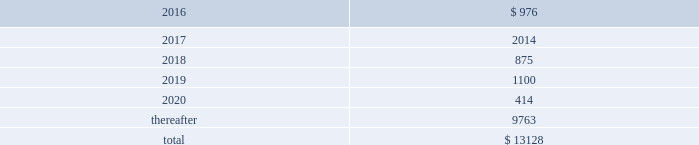Devon energy corporation and subsidiaries notes to consolidated financial statements 2013 ( continued ) debt maturities as of december 31 , 2015 , excluding premiums and discounts , are as follows ( millions ) : .
Credit lines devon has a $ 3.0 billion senior credit facility .
The maturity date for $ 30 million of the senior credit facility is october 24 , 2017 .
The maturity date for $ 164 million of the senior credit facility is october 24 , 2018 .
The maturity date for the remaining $ 2.8 billion is october 24 , 2019 .
Amounts borrowed under the senior credit facility may , at the election of devon , bear interest at various fixed rate options for periods of up to twelve months .
Such rates are generally less than the prime rate .
However , devon may elect to borrow at the prime rate .
The senior credit facility currently provides for an annual facility fee of $ 3.8 million that is payable quarterly in arrears .
As of december 31 , 2015 , there were no borrowings under the senior credit facility .
The senior credit facility contains only one material financial covenant .
This covenant requires devon 2019s ratio of total funded debt to total capitalization , as defined in the credit agreement , to be no greater than 65% ( 65 % ) .
The credit agreement contains definitions of total funded debt and total capitalization that include adjustments to the respective amounts reported in the accompanying consolidated financial statements .
Also , total capitalization is adjusted to add back noncash financial write-downs such as full cost ceiling impairments or goodwill impairments .
As of december 31 , 2015 , devon was in compliance with this covenant with a debt-to- capitalization ratio of 23.7% ( 23.7 % ) .
Commercial paper devon 2019s senior credit facility supports its $ 3.0 billion of short-term credit under its commercial paper program .
Commercial paper debt generally has a maturity of between 1 and 90 days , although it can have a maturity of up to 365 days , and bears interest at rates agreed to at the time of the borrowing .
The interest rate is generally based on a standard index such as the federal funds rate , libor or the money market rate as found in the commercial paper market .
As of december 31 , 2015 , devon 2019s outstanding commercial paper borrowings had a weighted-average borrowing rate of 0.63% ( 0.63 % ) .
Issuance of senior notes in june 2015 , devon issued $ 750 million of 5.0% ( 5.0 % ) senior notes due 2045 that are unsecured and unsubordinated obligations .
Devon used the net proceeds to repay the floating rate senior notes that matured on december 15 , 2015 , as well as outstanding commercial paper balances .
In december 2015 , in conjunction with the announcement of the powder river basin and stack acquisitions , devon issued $ 850 million of 5.85% ( 5.85 % ) senior notes due 2025 that are unsecured and unsubordinated obligations .
Devon used the net proceeds to fund the cash portion of these acquisitions. .
In millions , what was the mathematical range of debt maturities for 2018-2020? 
Computations: (1100 - 414)
Answer: 686.0. Devon energy corporation and subsidiaries notes to consolidated financial statements 2013 ( continued ) debt maturities as of december 31 , 2015 , excluding premiums and discounts , are as follows ( millions ) : .
Credit lines devon has a $ 3.0 billion senior credit facility .
The maturity date for $ 30 million of the senior credit facility is october 24 , 2017 .
The maturity date for $ 164 million of the senior credit facility is october 24 , 2018 .
The maturity date for the remaining $ 2.8 billion is october 24 , 2019 .
Amounts borrowed under the senior credit facility may , at the election of devon , bear interest at various fixed rate options for periods of up to twelve months .
Such rates are generally less than the prime rate .
However , devon may elect to borrow at the prime rate .
The senior credit facility currently provides for an annual facility fee of $ 3.8 million that is payable quarterly in arrears .
As of december 31 , 2015 , there were no borrowings under the senior credit facility .
The senior credit facility contains only one material financial covenant .
This covenant requires devon 2019s ratio of total funded debt to total capitalization , as defined in the credit agreement , to be no greater than 65% ( 65 % ) .
The credit agreement contains definitions of total funded debt and total capitalization that include adjustments to the respective amounts reported in the accompanying consolidated financial statements .
Also , total capitalization is adjusted to add back noncash financial write-downs such as full cost ceiling impairments or goodwill impairments .
As of december 31 , 2015 , devon was in compliance with this covenant with a debt-to- capitalization ratio of 23.7% ( 23.7 % ) .
Commercial paper devon 2019s senior credit facility supports its $ 3.0 billion of short-term credit under its commercial paper program .
Commercial paper debt generally has a maturity of between 1 and 90 days , although it can have a maturity of up to 365 days , and bears interest at rates agreed to at the time of the borrowing .
The interest rate is generally based on a standard index such as the federal funds rate , libor or the money market rate as found in the commercial paper market .
As of december 31 , 2015 , devon 2019s outstanding commercial paper borrowings had a weighted-average borrowing rate of 0.63% ( 0.63 % ) .
Issuance of senior notes in june 2015 , devon issued $ 750 million of 5.0% ( 5.0 % ) senior notes due 2045 that are unsecured and unsubordinated obligations .
Devon used the net proceeds to repay the floating rate senior notes that matured on december 15 , 2015 , as well as outstanding commercial paper balances .
In december 2015 , in conjunction with the announcement of the powder river basin and stack acquisitions , devon issued $ 850 million of 5.85% ( 5.85 % ) senior notes due 2025 that are unsecured and unsubordinated obligations .
Devon used the net proceeds to fund the cash portion of these acquisitions. .
In 2015 what was the ratio of the notes issued maturing in 2025 to 2045? 
Rationale: in 2015 there was $ 1.13 of notes maturing in 2025 for each $ 1 maturing in 2045
Computations: (850 / 750)
Answer: 1.13333. 